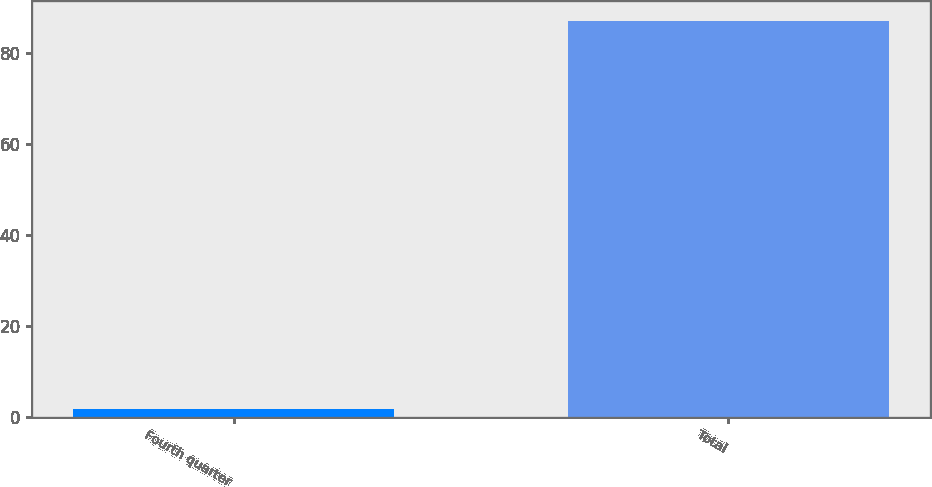<chart> <loc_0><loc_0><loc_500><loc_500><bar_chart><fcel>Fourth quarter<fcel>Total<nl><fcel>1.8<fcel>87<nl></chart> 